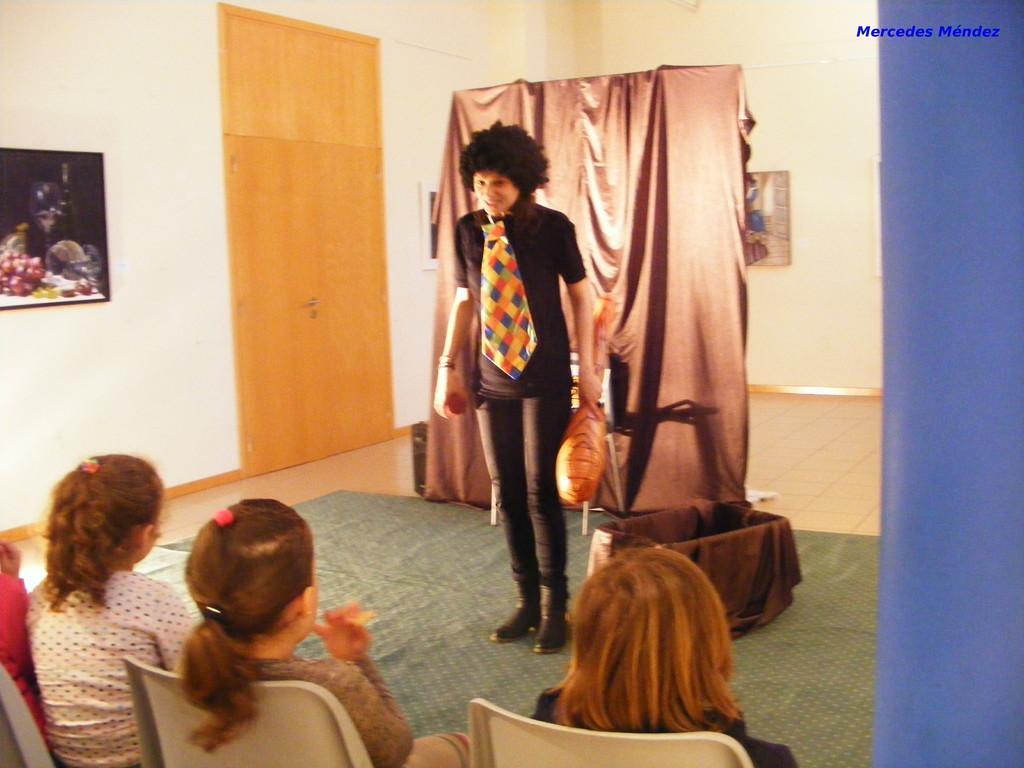In one or two sentences, can you explain what this image depicts? In this picture there is a woman who is wearing black dress, tie, shoes, gloves and holding a pillow. Beside her I can see the basket. Behind her I can see the cloth which is hanging on this pipe. On the left I can see the photo frame which is placed on the wall. Beside that there is a door. At the bottom I can see some girls who are sitting on the chair. In the top right corner there is a watermark. 